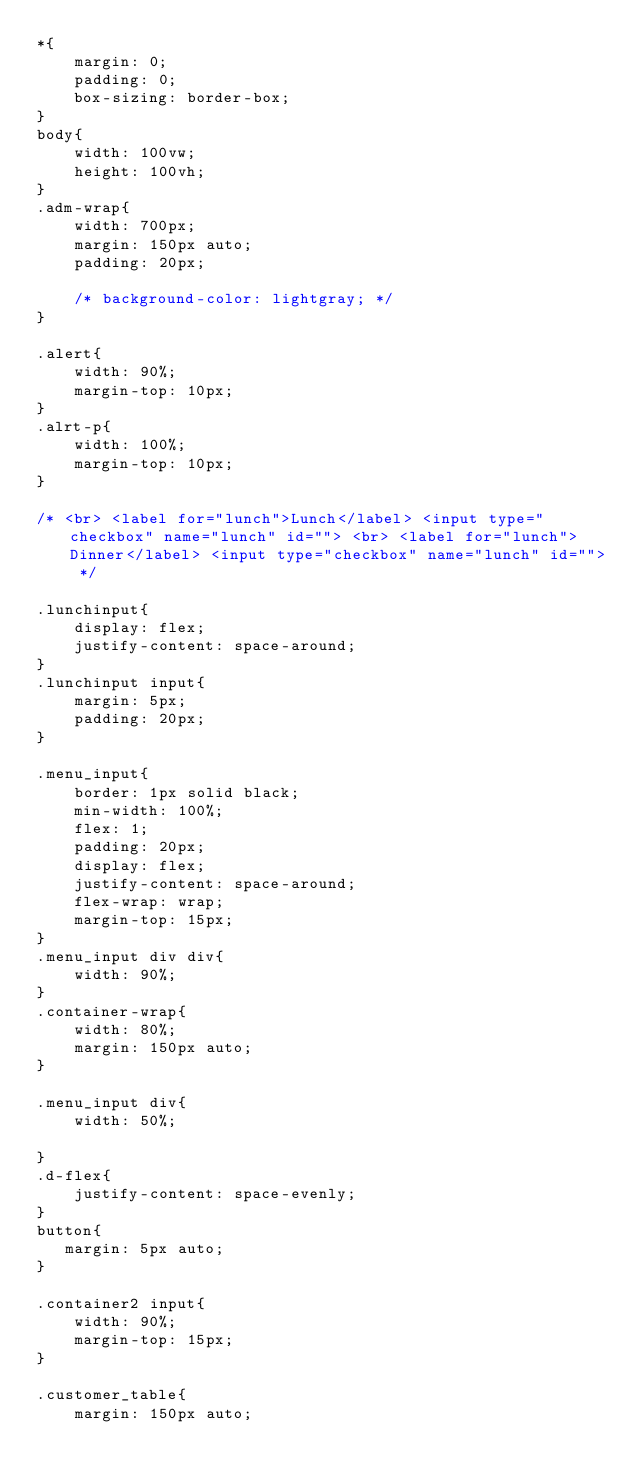Convert code to text. <code><loc_0><loc_0><loc_500><loc_500><_CSS_>*{
    margin: 0;
    padding: 0;
    box-sizing: border-box;
}
body{
    width: 100vw;
    height: 100vh;
}
.adm-wrap{
    width: 700px;
    margin: 150px auto;
    padding: 20px;
    
    /* background-color: lightgray; */
}

.alert{
    width: 90%;
    margin-top: 10px;
}
.alrt-p{
    width: 100%;
    margin-top: 10px;
}

/* <br> <label for="lunch">Lunch</label> <input type="checkbox" name="lunch" id=""> <br> <label for="lunch">Dinner</label> <input type="checkbox" name="lunch" id=""> */

.lunchinput{
    display: flex;
    justify-content: space-around;
}
.lunchinput input{
    margin: 5px;
    padding: 20px;
}

.menu_input{
    border: 1px solid black;
    min-width: 100%;
    flex: 1;
    padding: 20px;
    display: flex;
    justify-content: space-around;
    flex-wrap: wrap;
    margin-top: 15px;
}
.menu_input div div{
    width: 90%;
}
.container-wrap{
    width: 80%;
    margin: 150px auto;
}

.menu_input div{
    width: 50%;
   
}
.d-flex{
    justify-content: space-evenly;
}
button{
   margin: 5px auto;
}

.container2 input{
    width: 90%;
    margin-top: 15px;
}

.customer_table{
    margin: 150px auto;</code> 